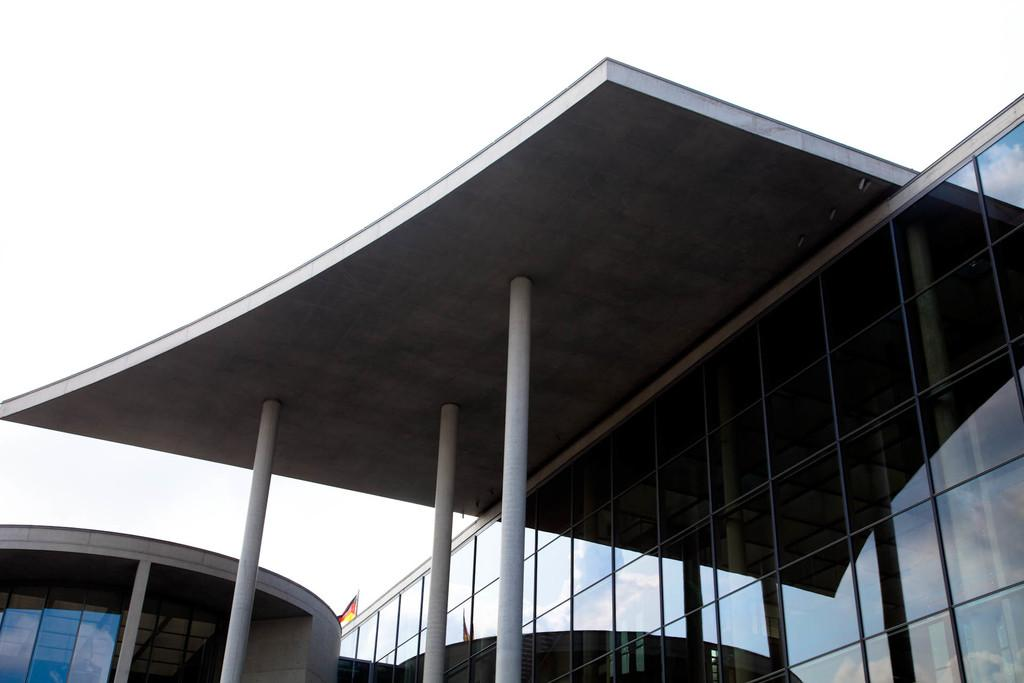What type of structures can be seen in the image? There are buildings in the image. What is visible at the top of the image? The sky is visible at the top of the image. How many eyes can be seen on the buildings in the image? There are no eyes present on the buildings in the image. What type of substance is being collected in the bucket in the image? There is no bucket or substance present in the image. 